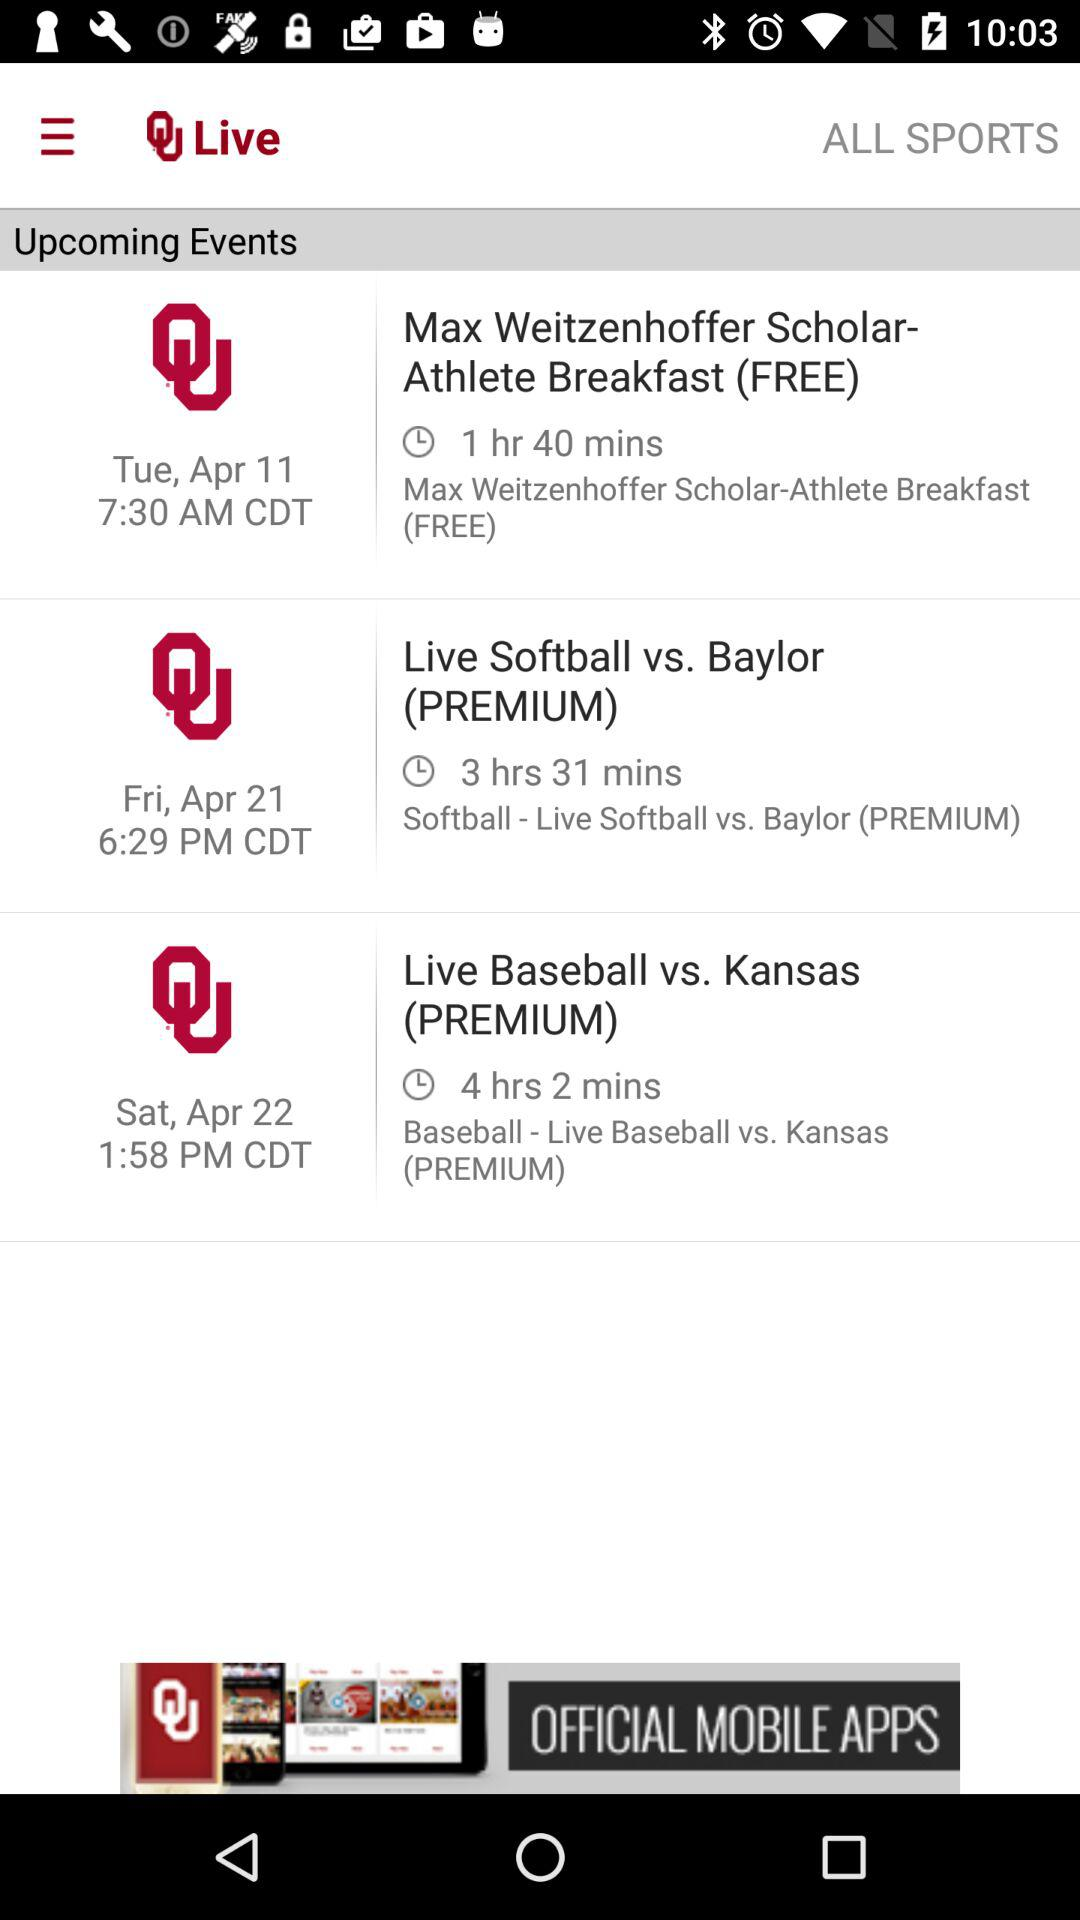Is "Upcoming Events" checked or unchecked?
When the provided information is insufficient, respond with <no answer>. <no answer> 